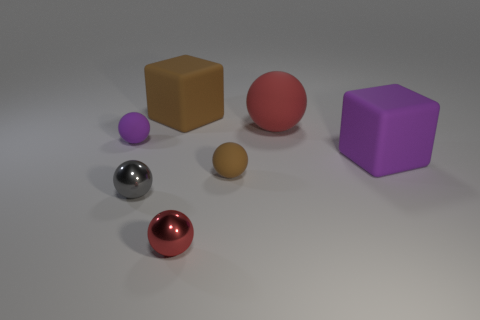Subtract all brown balls. How many balls are left? 4 Subtract all gray spheres. How many spheres are left? 4 Subtract all cyan spheres. Subtract all blue cubes. How many spheres are left? 5 Add 1 purple blocks. How many objects exist? 8 Subtract all blocks. How many objects are left? 5 Add 5 gray spheres. How many gray spheres exist? 6 Subtract 0 green spheres. How many objects are left? 7 Subtract all big brown objects. Subtract all metallic spheres. How many objects are left? 4 Add 6 purple rubber cubes. How many purple rubber cubes are left? 7 